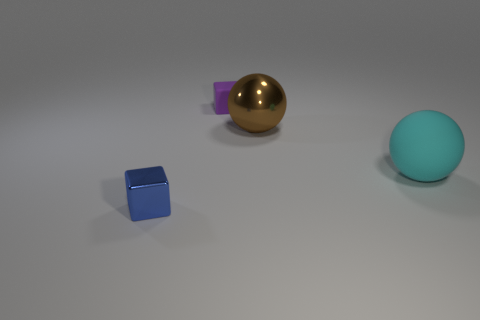Add 1 small cyan matte objects. How many objects exist? 5 Add 2 purple rubber objects. How many purple rubber objects exist? 3 Subtract 0 red cylinders. How many objects are left? 4 Subtract all metal cubes. Subtract all large cyan things. How many objects are left? 2 Add 2 blue metallic cubes. How many blue metallic cubes are left? 3 